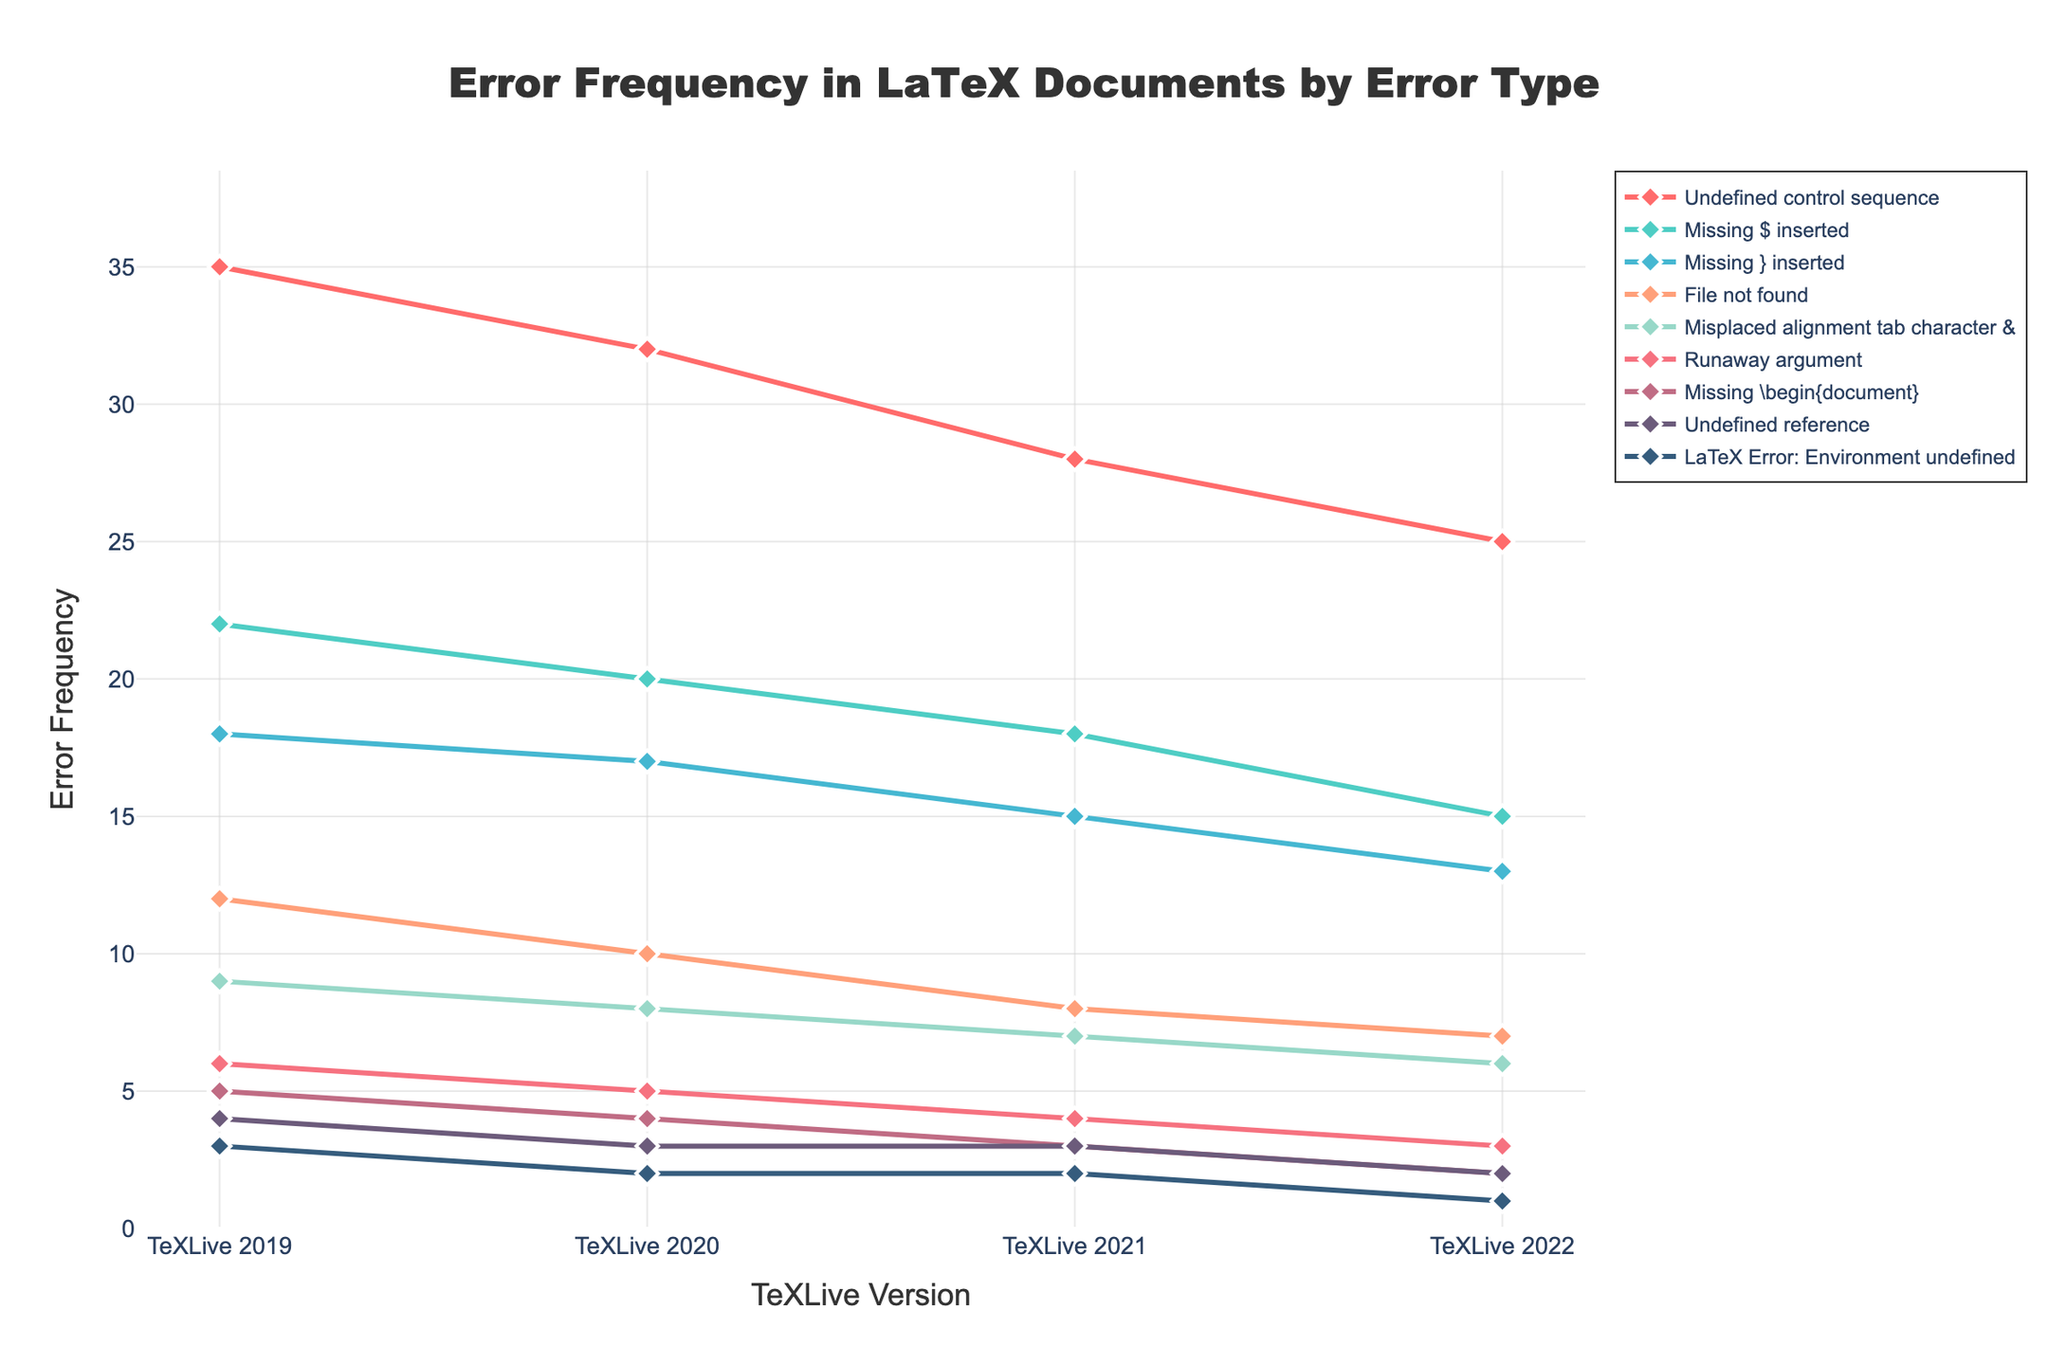Which error type had the highest frequency in TeXLive 2019? Look for the point on the TeXLive 2019 axis with the highest value. The highest point is for "Undefined control sequence" with a frequency of 35.
Answer: Undefined control sequence Did the frequency of any error type remain constant across all versions? Check each error's line across all versions. The error type "Undefined reference" remains constant between TeXLive 2021 and TeXLive 2022.
Answer: Undefined reference Which error type shows the greatest overall decrease in frequency from TeXLive 2019 to TeXLive 2022? Calculate the difference for each error type between TeXLive 2019 and TeXLive 2022. The greatest difference is for "Undefined control sequence" with a decrease from 35 to 25, which is a difference of 10.
Answer: Undefined control sequence What's the average frequency of "Missing $ inserted" errors across all TeXLive versions? Sum the frequencies for TeXLive 2019 to 2022 for "Missing $ inserted" and divide by 4. (22 + 20 + 18 + 15) = 75. Average is 75 / 4 = 18.75.
Answer: 18.75 Among TeXLive 2020, 2021, and 2022, which version had the lowest frequency of "File not found" errors? Check "File not found" error across TeXLive 2020, 2021, and 2022. The lowest frequency is in TeXLive 2022 with a value of 7.
Answer: TeXLive 2022 Which error type had the smallest frequency in TeXLive 2022? Look at the points on the TeXLive 2022 axis and find the smallest value. The smallest value is for "LaTeX Error: Environment undefined" with a frequency of 1.
Answer: LaTeX Error: Environment undefined What is the difference in the frequency of "Runaway argument" errors between TeXLive 2019 and TeXLive 2020? Subtract the frequency in TeXLive 2020 from that in TeXLive 2019 for "Runaway argument." This is 6 - 5 = 1.
Answer: 1 Are there more "Missing \begin{document}" errors in TeXLive 2019 or "Undefined reference" errors in TeXLive 2022? Compare the frequency of "Missing \begin{document}" errors in TeXLive 2019 with "Undefined reference" errors in TeXLive 2022. 5 > 2.
Answer: Missing \begin{document} errors in TeXLive 2019 What's the combined frequency of errors "Missing } inserted" and "Misplaced alignment tab character &" in TeXLive 2021? Sum the frequencies of these two errors in TeXLive 2021. 15 ("Missing } inserted") + 7 ("Misplaced alignment tab character &") = 22.
Answer: 22 